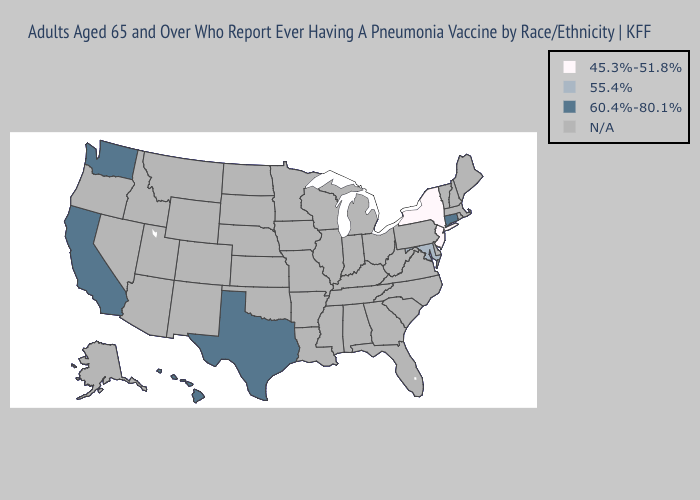Does Maryland have the highest value in the USA?
Keep it brief. No. What is the highest value in the Northeast ?
Give a very brief answer. 60.4%-80.1%. Name the states that have a value in the range 60.4%-80.1%?
Keep it brief. California, Connecticut, Hawaii, Texas, Washington. Does the first symbol in the legend represent the smallest category?
Short answer required. Yes. How many symbols are there in the legend?
Write a very short answer. 4. Name the states that have a value in the range 45.3%-51.8%?
Concise answer only. New Jersey, New York. Does the map have missing data?
Short answer required. Yes. Which states have the highest value in the USA?
Be succinct. California, Connecticut, Hawaii, Texas, Washington. Name the states that have a value in the range 55.4%?
Write a very short answer. Maryland. 